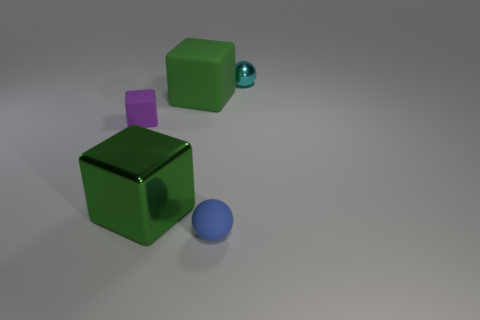Does the large metallic thing have the same color as the large matte cube?
Offer a very short reply. Yes. What number of other objects are the same material as the small cyan sphere?
Your response must be concise. 1. What is the size of the other green thing that is the same shape as the large green rubber object?
Make the answer very short. Large. What number of cyan objects are metal spheres or large objects?
Provide a short and direct response. 1. There is a tiny thing on the left side of the blue rubber sphere; how many big rubber cubes are behind it?
Offer a terse response. 1. How many other objects are there of the same shape as the large shiny thing?
Provide a succinct answer. 2. There is another big block that is the same color as the metallic cube; what material is it?
Keep it short and to the point. Rubber. What number of large blocks have the same color as the big shiny object?
Offer a very short reply. 1. What color is the tiny sphere that is the same material as the small purple cube?
Offer a very short reply. Blue. Are there any purple rubber blocks of the same size as the cyan sphere?
Your answer should be very brief. Yes. 